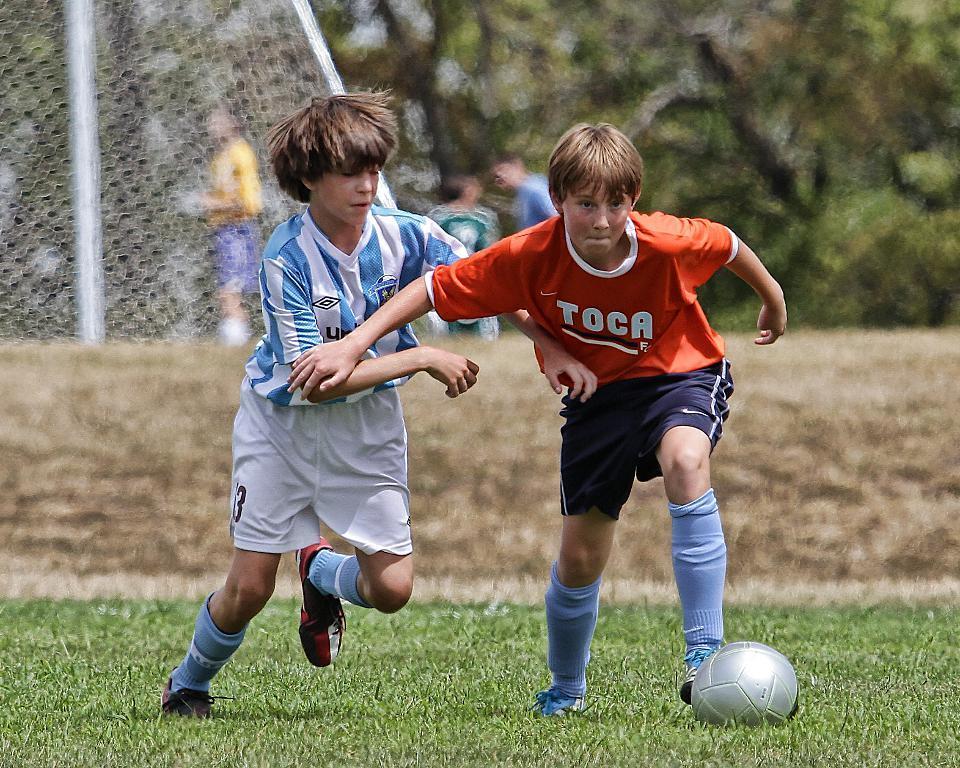Can you describe this image briefly? In this picture, we see two boys are running. In front of them, we see a ball. I think they are playing the football. At the bottom, we see the grass. Behind them, we see the fence or a net. Behind that, we see the people are standing. There are trees in the background. This picture is blurred in the background. 